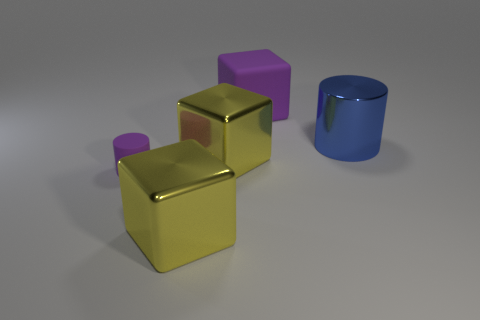There is a yellow thing behind the rubber thing in front of the purple rubber object behind the large cylinder; what is its shape?
Provide a succinct answer. Cube. There is a small purple object; what shape is it?
Ensure brevity in your answer.  Cylinder. There is a large object behind the large blue cylinder; what is its color?
Keep it short and to the point. Purple. Do the cylinder in front of the blue shiny object and the purple matte block have the same size?
Provide a short and direct response. No. What size is the other object that is the same shape as the small matte thing?
Your response must be concise. Large. Is there any other thing that is the same size as the blue metal cylinder?
Provide a short and direct response. Yes. Is the shape of the tiny purple thing the same as the big purple rubber object?
Your answer should be very brief. No. Is the number of matte things behind the metal cylinder less than the number of big blocks that are behind the purple cube?
Offer a very short reply. No. How many small objects are left of the tiny purple rubber cylinder?
Provide a short and direct response. 0. There is a purple object in front of the blue object; does it have the same shape as the rubber thing that is behind the metal cylinder?
Ensure brevity in your answer.  No. 